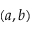Convert formula to latex. <formula><loc_0><loc_0><loc_500><loc_500>( a , b )</formula> 